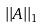Convert formula to latex. <formula><loc_0><loc_0><loc_500><loc_500>| | A | | _ { 1 }</formula> 